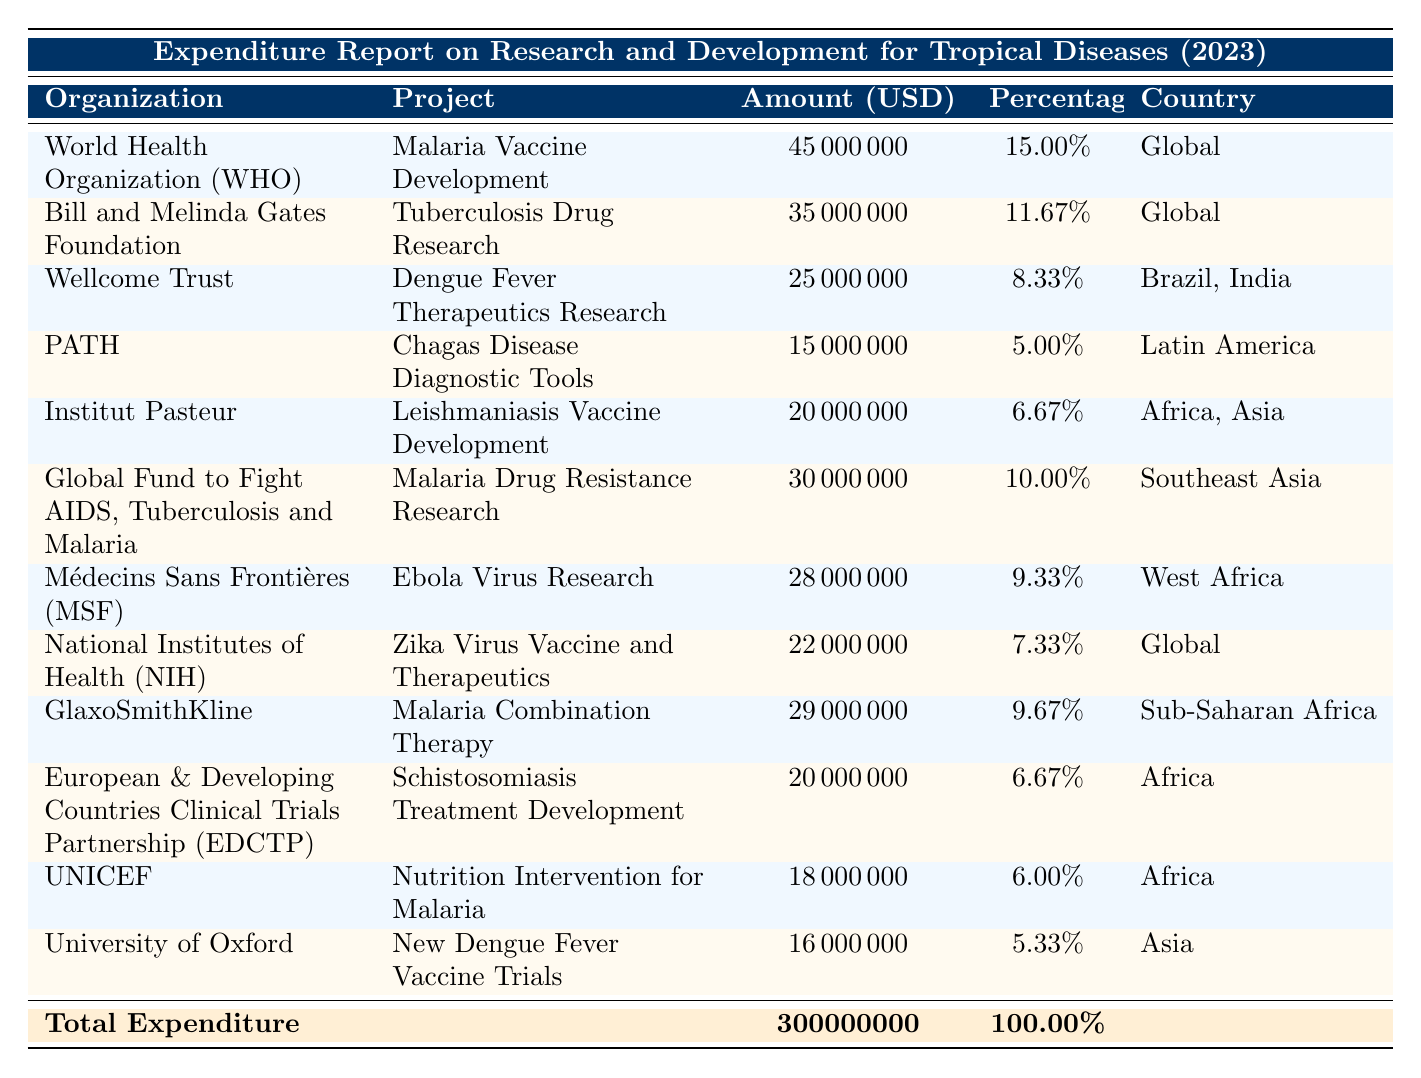What is the total expenditure reported in the table? The total expenditure is presented in the last row of the table, listed under "Total Expenditure," which states the amount as 300000000 USD.
Answer: 300000000 USD Which organization has allocated the highest amount for research and development? By examining the "Amount" column, the World Health Organization (WHO) is listed first with an expenditure of 45000000, which is the highest compared to all other organizations.
Answer: World Health Organization (WHO) What percentage of the total expenditure was allocated to tuberculosis drug research? The "Amount" for tuberculosis drug research by the Bill and Melinda Gates Foundation is 35000000. To find the percentage, divide this amount by the total expenditure (300000000) and multiply by 100, resulting in (35000000/300000000)*100 = 11.67%.
Answer: 11.67% Are there any projects focused specifically on Africa? Reviewing the "Country" column, there are three projects that specifically mention Africa: Leishmaniasis Vaccine Development, Schistosomiasis Treatment Development, and Nutrition Intervention for Malaria. Therefore, the answer is yes.
Answer: Yes What is the difference in expenditure between malaria vaccine development and Chagas disease diagnostic tools? Expenditure for malaria vaccine development by the WHO is 45000000, while for Chagas disease diagnostic tools by PATH it is 15000000. To find the difference, subtract the amount for Chagas from malaria: 45000000 - 15000000 = 30000000.
Answer: 30000000 Which project received the smallest funding and what is the amount? By examining the "Amount" column, the project with the smallest amount is the University of Oxford's project "New Dengue Fever Vaccine Trials" with an expenditure of 16000000.
Answer: New Dengue Fever Vaccine Trials, 16000000 What is the combined funding for all malaria-related projects? The relevant projects are Malaria Vaccine Development (45000000), Malaria Drug Resistance Research (30000000), and Malaria Combination Therapy (29000000). Adding these amounts gives 45000000 + 30000000 + 29000000 = 104000000.
Answer: 104000000 Is the funding for Zika Virus Vaccine and Therapeutics greater than that for Ebola Virus Research? The funding for Zika Virus Vaccine and Therapeutics is 22000000 and for Ebola Virus Research, it is 28000000. Comparing these, 22000000 is less than 28000000, so the answer is no.
Answer: No What is the average funding allocated to projects based in Africa? The projects based in Africa are Leishmaniasis Vaccine Development (20000000), Schistosomiasis Treatment Development (20000000), and Nutrition Intervention for Malaria (18000000). The total for these is 20000000 + 20000000 + 18000000 = 58000000, divided by 3 projects gives an average of 58000000 / 3 = 19333333.33.
Answer: 19333333.33 